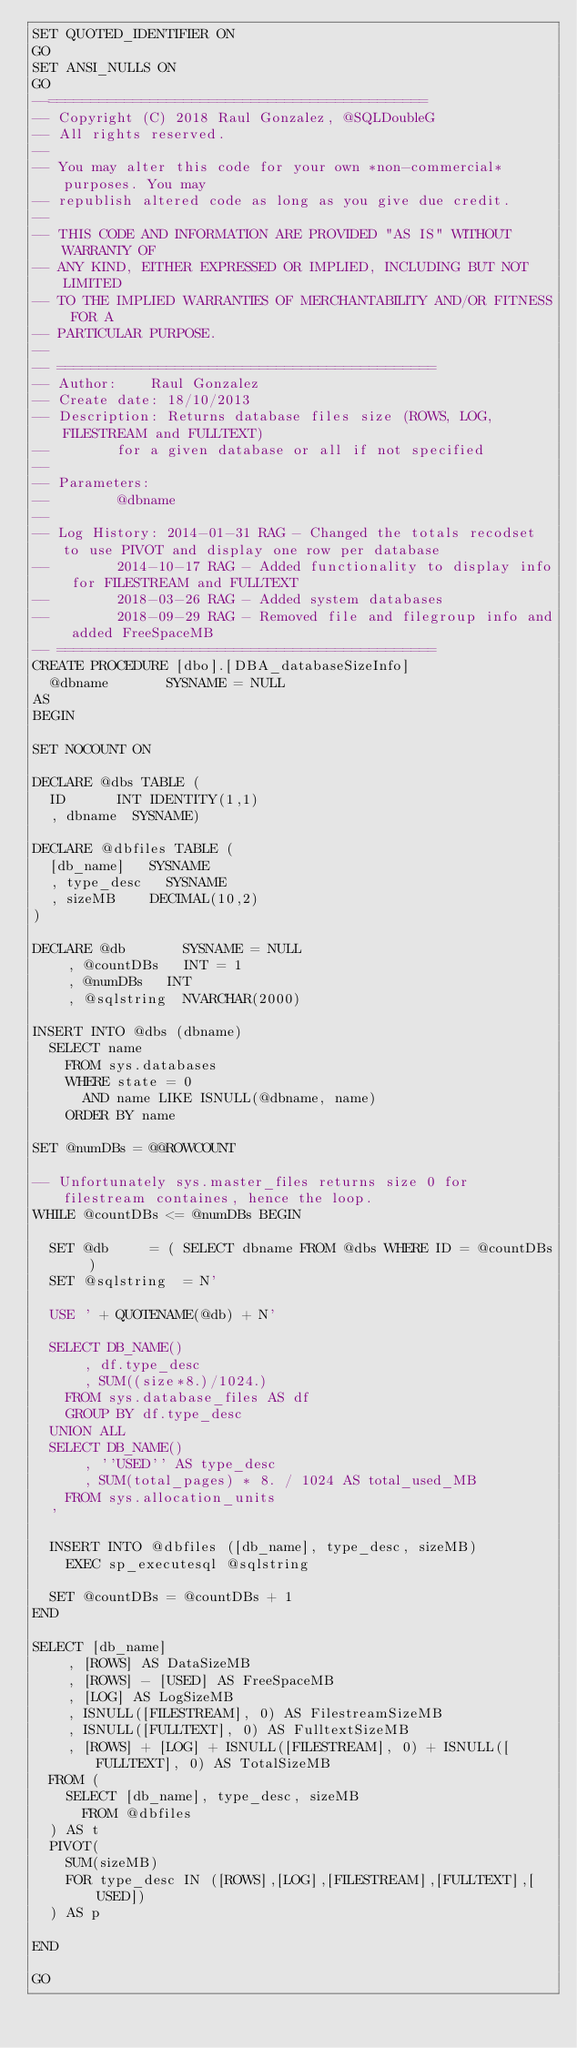<code> <loc_0><loc_0><loc_500><loc_500><_SQL_>SET QUOTED_IDENTIFIER ON
GO
SET ANSI_NULLS ON
GO
--=============================================
-- Copyright (C) 2018 Raul Gonzalez, @SQLDoubleG
-- All rights reserved.
--   
-- You may alter this code for your own *non-commercial* purposes. You may
-- republish altered code as long as you give due credit.
--   
-- THIS CODE AND INFORMATION ARE PROVIDED "AS IS" WITHOUT WARRANTY OF 
-- ANY KIND, EITHER EXPRESSED OR IMPLIED, INCLUDING BUT NOT LIMITED 
-- TO THE IMPLIED WARRANTIES OF MERCHANTABILITY AND/OR FITNESS FOR A
-- PARTICULAR PURPOSE.
--
-- =============================================
-- Author:		Raul Gonzalez
-- Create date: 18/10/2013
-- Description:	Returns database files size (ROWS, LOG, FILESTREAM and FULLTEXT)
--				for a given database or all if not specified
--
-- Parameters:
--				@dbname
--
-- Log History:	2014-01-31 RAG - Changed the totals recodset to use PIVOT and display one row per database
--				2014-10-17 RAG - Added functionality to display info for FILESTREAM and FULLTEXT
--				2018-03-26 RAG - Added system databases
--				2018-09-29 RAG - Removed file and filegroup info and added FreeSpaceMB
-- =============================================
CREATE PROCEDURE [dbo].[DBA_databaseSizeInfo]
	@dbname				SYSNAME = NULL
AS
BEGIN

SET NOCOUNT ON

DECLARE @dbs TABLE (
	ID			INT IDENTITY(1,1)
	, dbname	SYSNAME)

DECLARE @dbfiles TABLE (
	[db_name]		SYSNAME
	, type_desc		SYSNAME
	, sizeMB		DECIMAL(10,2)
)

DECLARE @db				SYSNAME = NULL
		, @countDBs		INT = 1
		, @numDBs		INT
		, @sqlstring	NVARCHAR(2000)

INSERT INTO @dbs (dbname)
	SELECT name 
		FROM sys.databases 
		WHERE state = 0 
			AND name LIKE ISNULL(@dbname, name)
		ORDER BY name

SET @numDBs = @@ROWCOUNT
 
-- Unfortunately sys.master_files returns size 0 for filestream containes, hence the loop.
WHILE @countDBs <= @numDBs BEGIN

	SET @db			= ( SELECT dbname FROM @dbs WHERE ID = @countDBs )
	SET @sqlstring	= N'
		
	USE ' + QUOTENAME(@db) + N'
		
	SELECT DB_NAME()
			, df.type_desc
			, SUM((size*8.)/1024.)
		FROM sys.database_files AS df
		GROUP BY df.type_desc
	UNION ALL
	SELECT DB_NAME()
			, ''USED'' AS type_desc
			, SUM(total_pages) * 8. / 1024 AS total_used_MB  
		FROM sys.allocation_units
	'
	
	INSERT INTO @dbfiles ([db_name], type_desc, sizeMB)
		EXEC sp_executesql @sqlstring

	SET @countDBs = @countDBs + 1
END

SELECT [db_name] 
		, [ROWS] AS DataSizeMB
		, [ROWS] - [USED] AS FreeSpaceMB
		, [LOG] AS LogSizeMB
		, ISNULL([FILESTREAM], 0) AS FilestreamSizeMB
		, ISNULL([FULLTEXT], 0) AS FulltextSizeMB
		, [ROWS] + [LOG] + ISNULL([FILESTREAM], 0) + ISNULL([FULLTEXT], 0) AS TotalSizeMB
	FROM ( 
		SELECT [db_name], type_desc, sizeMB
			FROM @dbfiles 
	) AS t
	PIVOT(
		SUM(sizeMB)
		FOR type_desc IN ([ROWS],[LOG],[FILESTREAM],[FULLTEXT],[USED])
	) AS p

END

GO
</code> 